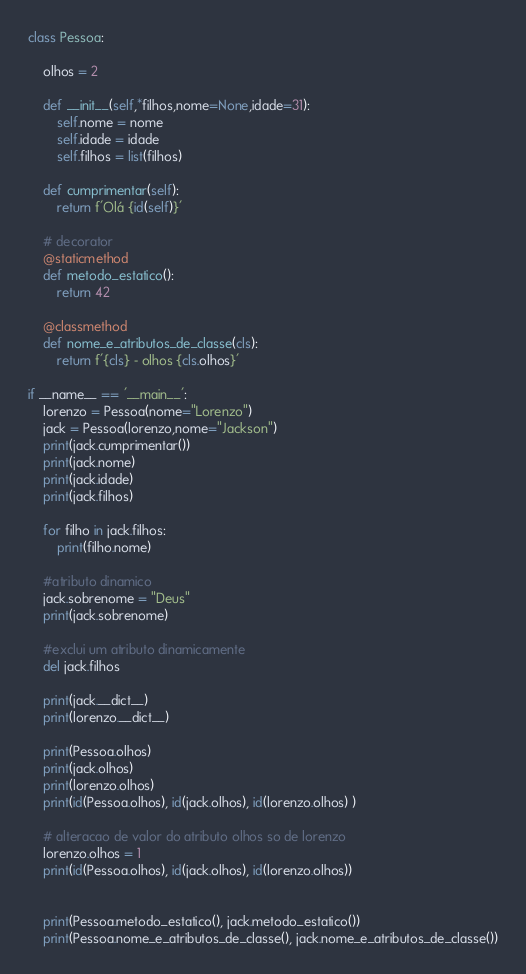Convert code to text. <code><loc_0><loc_0><loc_500><loc_500><_Python_>class Pessoa:

    olhos = 2

    def __init__(self,*filhos,nome=None,idade=31):
        self.nome = nome
        self.idade = idade
        self.filhos = list(filhos)

    def cumprimentar(self):
        return f'Olá {id(self)}'

    # decorator
    @staticmethod
    def metodo_estatico():
        return 42

    @classmethod
    def nome_e_atributos_de_classe(cls):
        return f'{cls} - olhos {cls.olhos}'

if __name__ == '__main__':
    lorenzo = Pessoa(nome="Lorenzo")
    jack = Pessoa(lorenzo,nome="Jackson")
    print(jack.cumprimentar())
    print(jack.nome)
    print(jack.idade)
    print(jack.filhos)

    for filho in jack.filhos:
        print(filho.nome)

    #atributo dinamico
    jack.sobrenome = "Deus"
    print(jack.sobrenome)

    #exclui um atributo dinamicamente
    del jack.filhos

    print(jack.__dict__)
    print(lorenzo.__dict__)

    print(Pessoa.olhos)
    print(jack.olhos)
    print(lorenzo.olhos)
    print(id(Pessoa.olhos), id(jack.olhos), id(lorenzo.olhos) )

    # alteracao de valor do atributo olhos so de lorenzo
    lorenzo.olhos = 1
    print(id(Pessoa.olhos), id(jack.olhos), id(lorenzo.olhos))


    print(Pessoa.metodo_estatico(), jack.metodo_estatico())
    print(Pessoa.nome_e_atributos_de_classe(), jack.nome_e_atributos_de_classe())</code> 